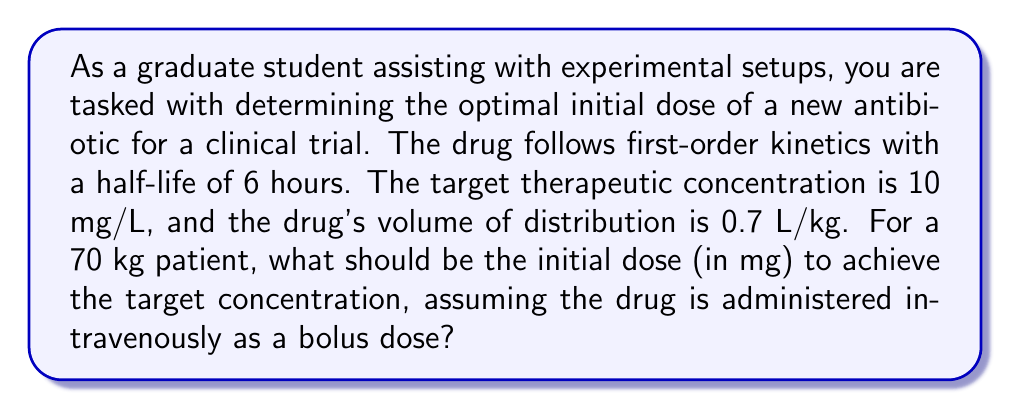Show me your answer to this math problem. To solve this problem, we'll use pharmacokinetic modeling and the exponential decay function. Let's break it down step-by-step:

1. First, we need to understand the relationship between dose, volume of distribution, and concentration:

   $C = \frac{Dose}{V_d}$

   Where $C$ is the concentration, $Dose$ is the amount of drug administered, and $V_d$ is the volume of distribution.

2. Calculate the total volume of distribution for the patient:
   
   $V_d = 0.7 \text{ L/kg} \times 70 \text{ kg} = 49 \text{ L}$

3. The first-order kinetics follow an exponential decay function:

   $C(t) = C_0 e^{-kt}$

   Where $C(t)$ is the concentration at time $t$, $C_0$ is the initial concentration, and $k$ is the elimination rate constant.

4. We can calculate $k$ using the half-life $(t_{1/2})$:

   $k = \frac{\ln(2)}{t_{1/2}} = \frac{\ln(2)}{6 \text{ hours}} = 0.1155 \text{ hour}^{-1}$

5. Since we want the initial concentration $(C_0)$ to be 10 mg/L, we can use the dose equation:

   $Dose = C_0 \times V_d = 10 \text{ mg/L} \times 49 \text{ L} = 490 \text{ mg}$

This initial dose will achieve the target concentration of 10 mg/L immediately after administration. However, due to the drug's elimination, the concentration will decrease over time according to the exponential decay function:

$C(t) = 10 \text{ mg/L} \times e^{-0.1155t}$

To maintain the therapeutic concentration, subsequent doses or a continuous infusion would be necessary, but that's beyond the scope of this initial dosing calculation.
Answer: The optimal initial dose for the 70 kg patient to achieve the target concentration of 10 mg/L is 490 mg. 